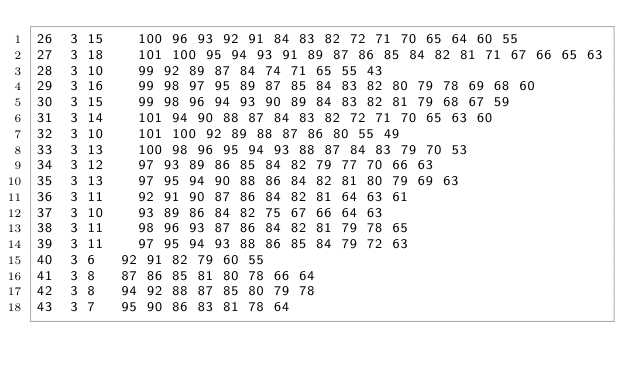<code> <loc_0><loc_0><loc_500><loc_500><_ObjectiveC_>26	3	15		100 96 93 92 91 84 83 82 72 71 70 65 64 60 55 
27	3	18		101 100 95 94 93 91 89 87 86 85 84 82 81 71 67 66 65 63 
28	3	10		99 92 89 87 84 74 71 65 55 43 
29	3	16		99 98 97 95 89 87 85 84 83 82 80 79 78 69 68 60 
30	3	15		99 98 96 94 93 90 89 84 83 82 81 79 68 67 59 
31	3	14		101 94 90 88 87 84 83 82 72 71 70 65 63 60 
32	3	10		101 100 92 89 88 87 86 80 55 49 
33	3	13		100 98 96 95 94 93 88 87 84 83 79 70 53 
34	3	12		97 93 89 86 85 84 82 79 77 70 66 63 
35	3	13		97 95 94 90 88 86 84 82 81 80 79 69 63 
36	3	11		92 91 90 87 86 84 82 81 64 63 61 
37	3	10		93 89 86 84 82 75 67 66 64 63 
38	3	11		98 96 93 87 86 84 82 81 79 78 65 
39	3	11		97 95 94 93 88 86 85 84 79 72 63 
40	3	6		92 91 82 79 60 55 
41	3	8		87 86 85 81 80 78 66 64 
42	3	8		94 92 88 87 85 80 79 78 
43	3	7		95 90 86 83 81 78 64 </code> 